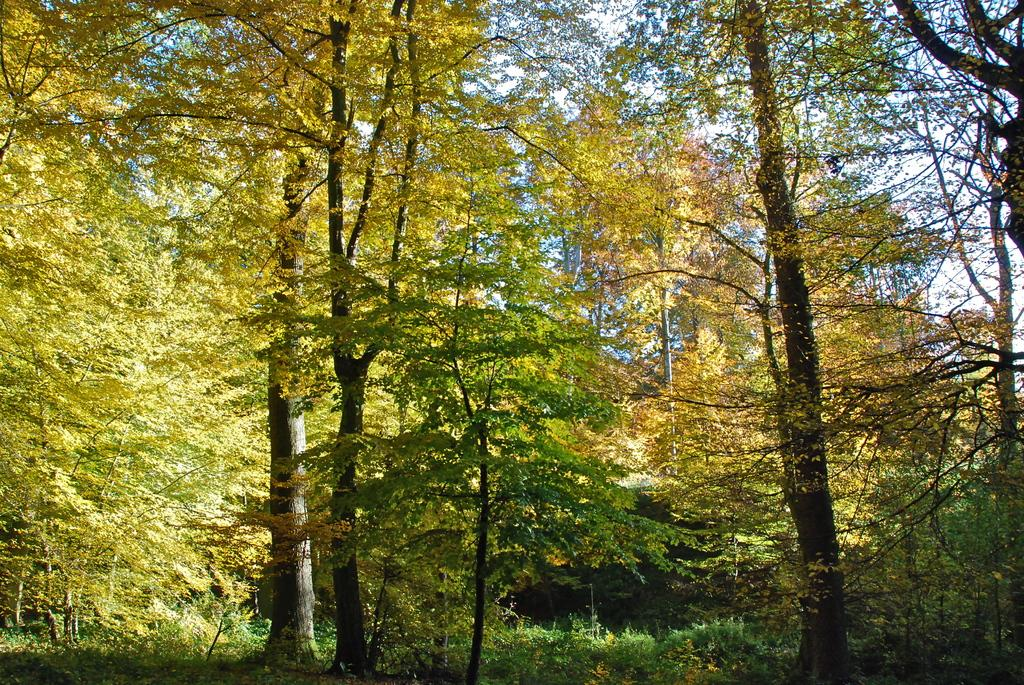What is the primary feature of the image? The primary feature of the image is the presence of many trees. How are the trees distributed in the image? The trees are spread across the land in the image. How many steps does it take to reach the lizards in the image? There are no lizards present in the image, so it is not possible to determine how many steps it would take to reach them. 